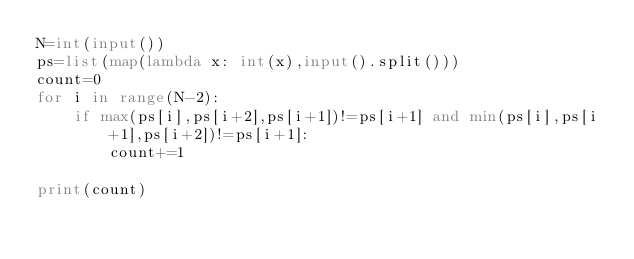Convert code to text. <code><loc_0><loc_0><loc_500><loc_500><_Python_>N=int(input())
ps=list(map(lambda x: int(x),input().split()))
count=0
for i in range(N-2):
    if max(ps[i],ps[i+2],ps[i+1])!=ps[i+1] and min(ps[i],ps[i+1],ps[i+2])!=ps[i+1]:
        count+=1

print(count)</code> 